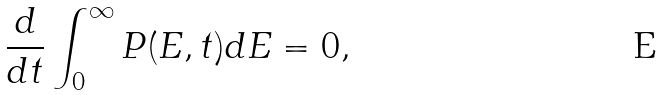<formula> <loc_0><loc_0><loc_500><loc_500>\frac { d } { d t } \int _ { 0 } ^ { \infty } P ( E , t ) d E = 0 ,</formula> 